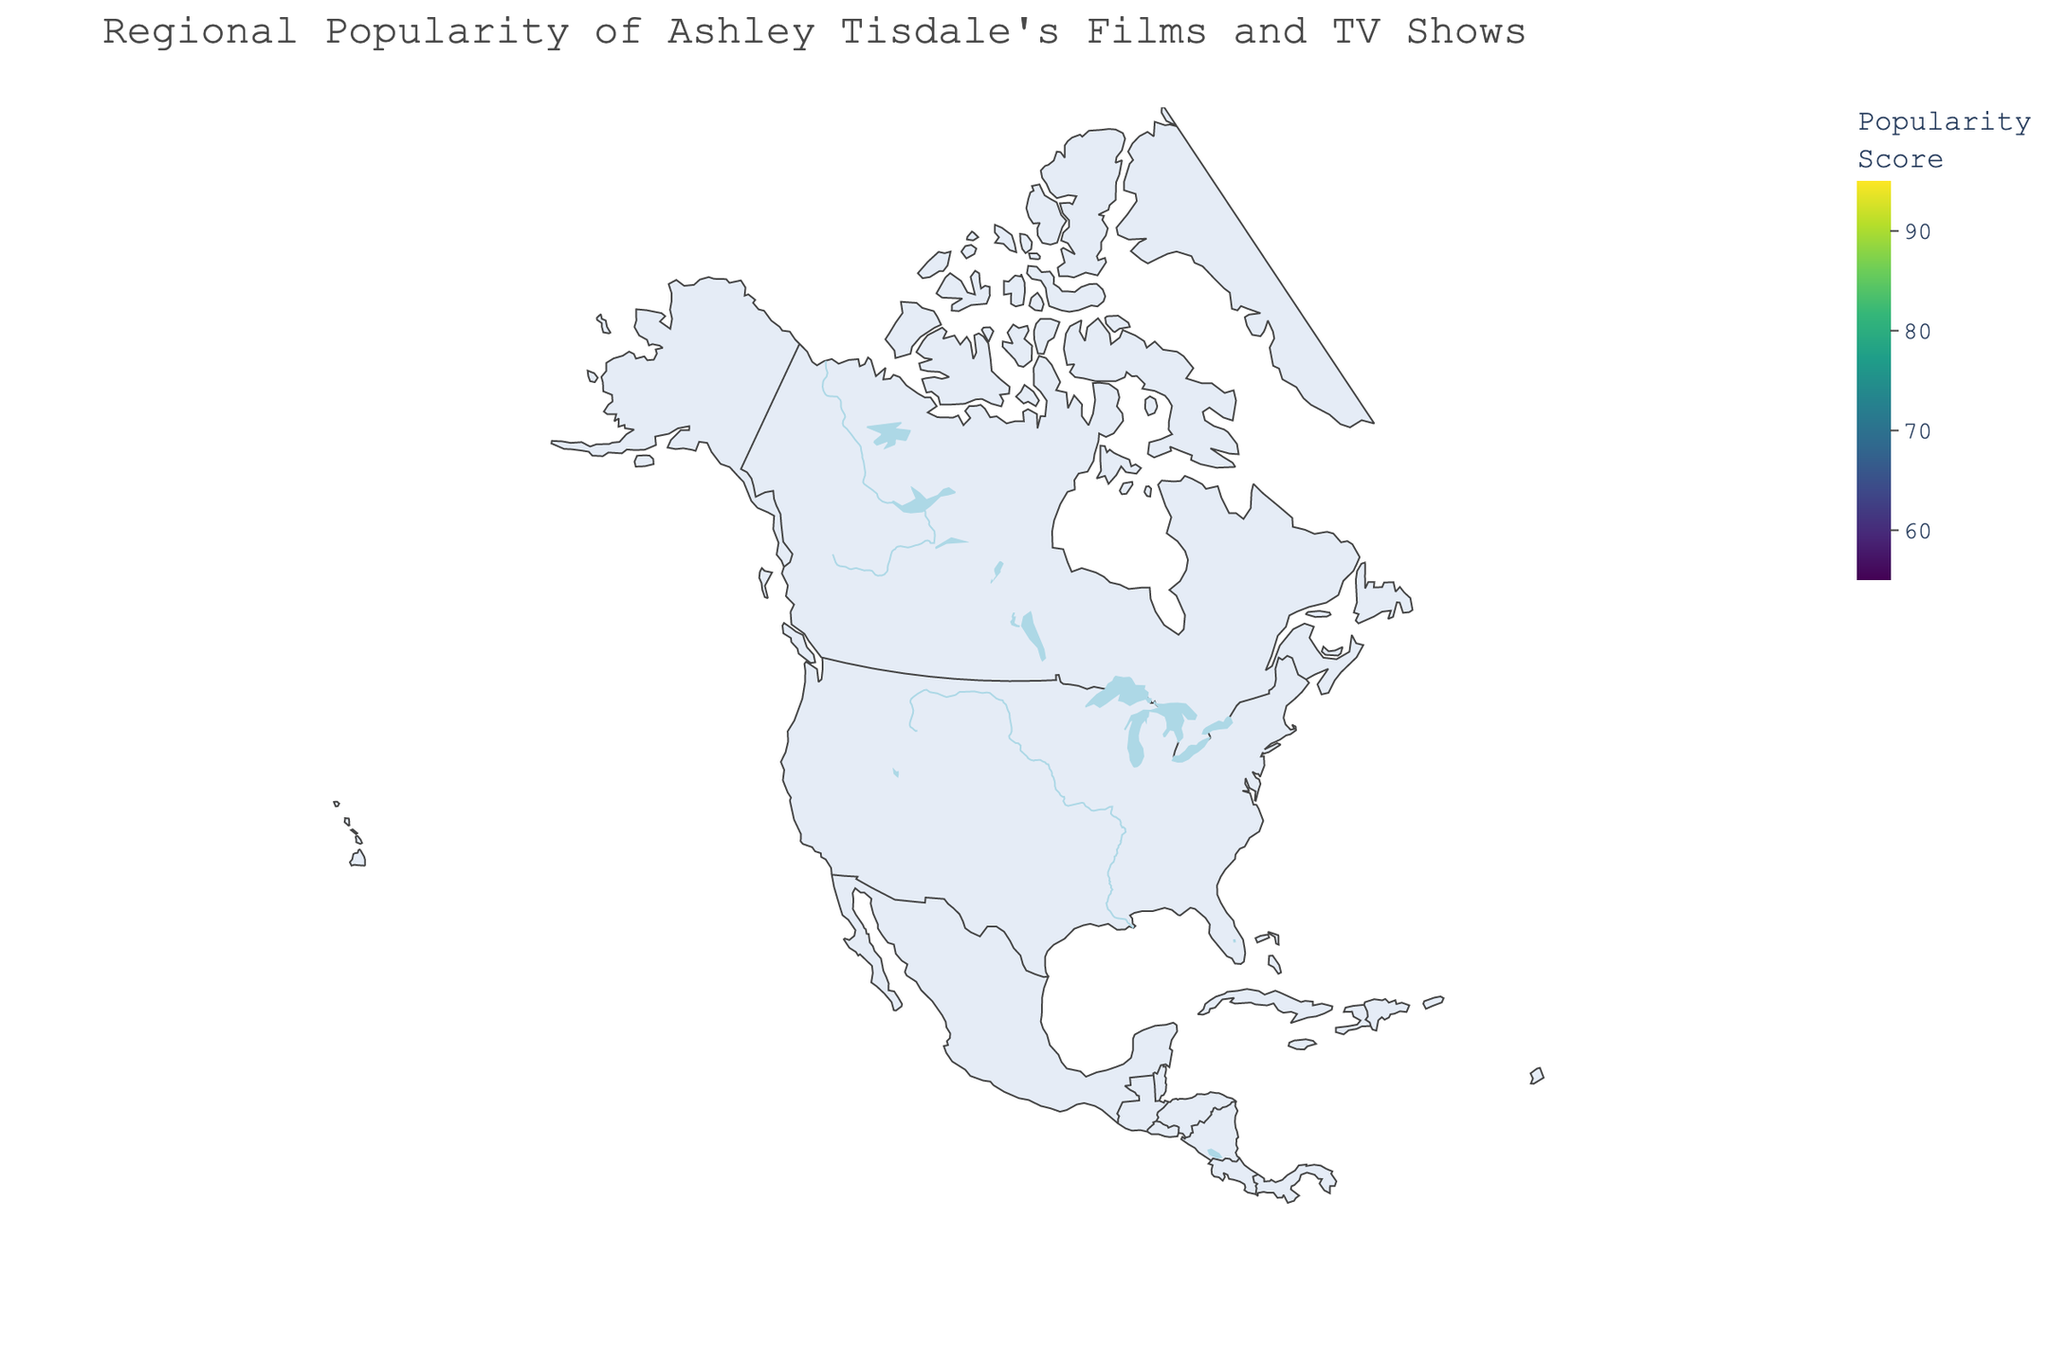What's the title of the geographic plot? The title of the plot is located at the top of the figure, often providing quick insight into the overall subject of the visualization.
Answer: Regional Popularity of Ashley Tisdale's Films and TV Shows Which US state has the highest popularity score? By observing the colors which indicate popularity scores, California is the darkest region representing the highest score.
Answer: California What's the popularity score of Ashley Tisdale's productions in Texas? By identifying Texas on the map and referring to the associated score in the legend or color bar, we find that Texas has a score of 75.
Answer: 75 How does Florida's popularity score compare to Illinois' score? By locating both regions on the figure and comparing their respective colors, we see that Florida's popularity score (82) is higher than Illinois' (70).
Answer: Florida has a higher score Among the Canadian provinces shown, which one has the lowest popularity score? Examining the colors of the Canadian provinces and referring to the legend, Quebec appears as the lightest, indicating the lowest score.
Answer: Quebec What's the average popularity score for the states: Michigan, Washington, and Arizona? First, gather the scores for Michigan (63), Washington (69), and Arizona (76). Sum these scores: 63 + 69 + 76 = 208. Then, divide by 3 to find the average: 208 / 3.
Answer: 69.33 Which state between Ohio and New Jersey has a higher popularity score for Ashley Tisdale's shows and films? By comparing the color shading or directly referring to the legend, New Jersey (71) has a higher score than Ohio (65).
Answer: New Jersey What is the total sum of popularity scores for the states in the eastern US: New York, Florida, and Georgia? Sum the given popularity scores: New York (88), Florida (82), and Georgia (78). The total sum is: 88 + 82 + 78.
Answer: 248 What visual elements are used to represent popular scores on this map? The map uses a color scale ranging from light to dark shades, with the legend showing the range (55 to 95) to indicate different popularity scores.
Answer: Color scale from light to dark What's the difference in popularity scores between Massachusetts and Virginia? Retrieve the scores for Massachusetts (73) and Virginia (67), then subtract the smaller score from the larger score: 73 - 67.
Answer: 6 